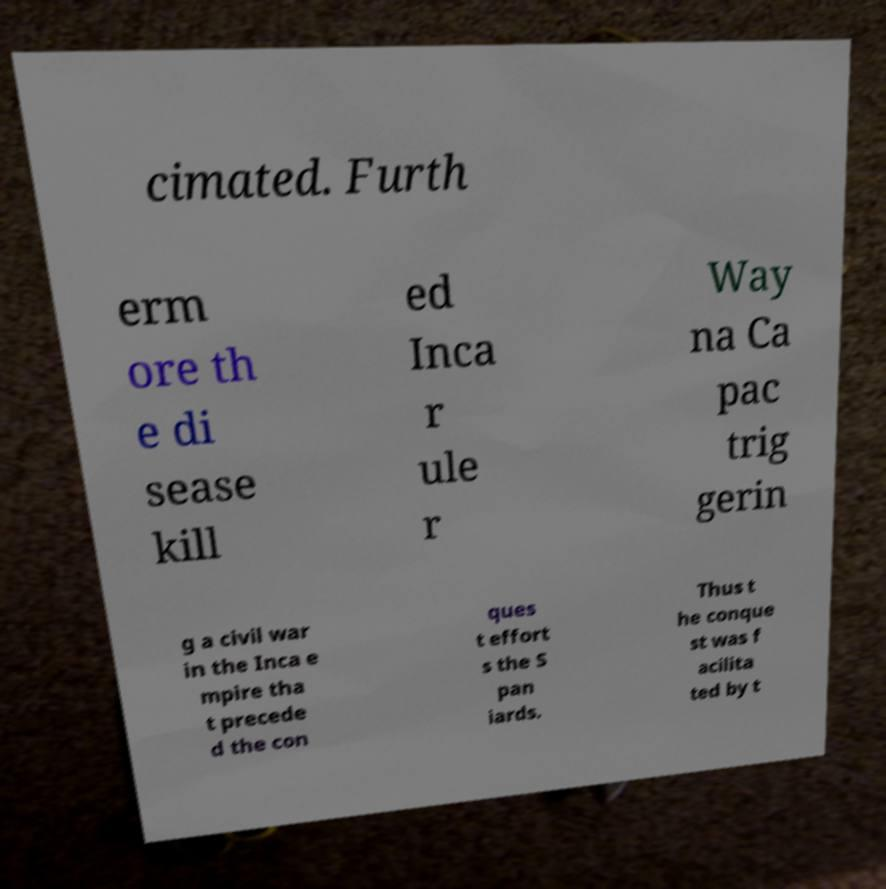Could you assist in decoding the text presented in this image and type it out clearly? cimated. Furth erm ore th e di sease kill ed Inca r ule r Way na Ca pac trig gerin g a civil war in the Inca e mpire tha t precede d the con ques t effort s the S pan iards. Thus t he conque st was f acilita ted by t 